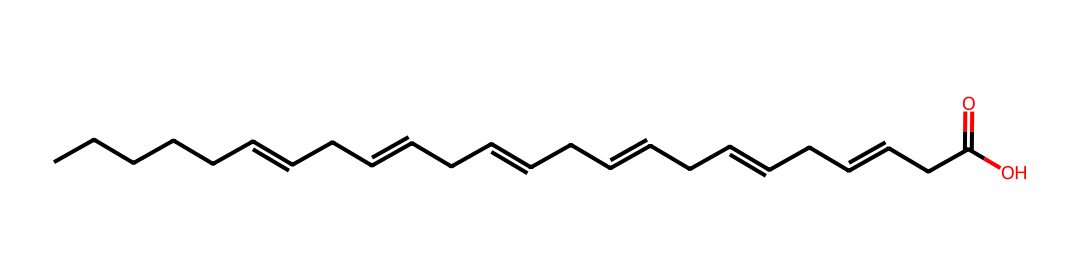What is the main functional group present in this chemical? The chemical structure contains a carboxylic acid group (indicated by the -COOH at the end of the hydrocarbon chain), which is characteristic of fatty acids.
Answer: carboxylic acid How many double bonds are present in this structure? By examining the structure, it can be observed that there are three instances of double bonds within the carbon chain (indicated by the "=" signs).
Answer: three What is the total number of carbon atoms in this molecule? Counting the carbon atoms represented in the SMILES, there are a total of 18 carbon atoms in the structure (each "C" in the SMILES represents one carbon).
Answer: 18 Is this molecule saturated or unsaturated? The presence of double bonds in the structure indicates that it has fewer than the maximum number of hydrogen atoms bonded to the carbon atoms, which classifies it as unsaturated.
Answer: unsaturated What type of lipid does this structure represent? Given the presence of multiple double bonds along with a long hydrocarbon chain, this structure is identified as an omega-3 fatty acid, which is a type of polyunsaturated fatty acid.
Answer: omega-3 fatty acid 